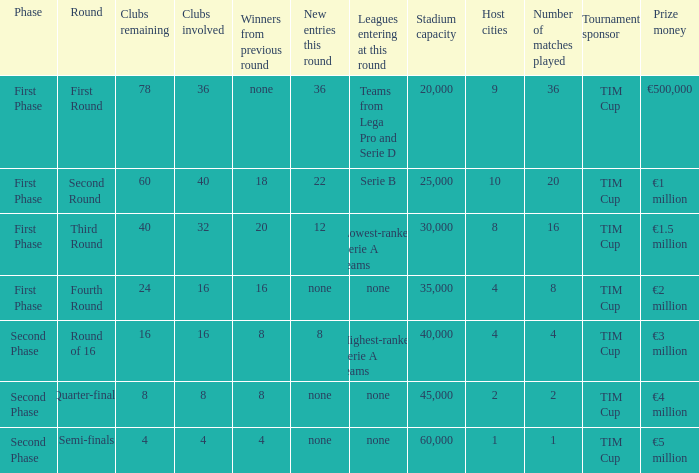Clubs involved is 8, what number would you find from winners from previous round? 8.0. 